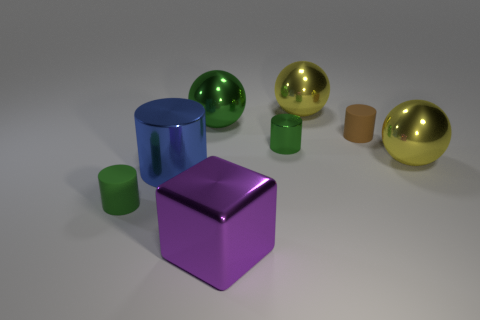Are there an equal number of brown rubber objects that are behind the large block and large green spheres?
Provide a short and direct response. Yes. Is the size of the brown cylinder the same as the yellow object that is right of the tiny brown rubber object?
Keep it short and to the point. No. What shape is the big yellow metal thing that is behind the tiny brown object?
Offer a terse response. Sphere. Is there anything else that has the same shape as the green matte thing?
Ensure brevity in your answer.  Yes. Are any small brown rubber cylinders visible?
Provide a short and direct response. Yes. There is a matte cylinder to the left of the small brown matte cylinder; is its size the same as the yellow metallic object behind the green metallic cylinder?
Your response must be concise. No. The small thing that is both right of the large purple object and in front of the brown object is made of what material?
Your response must be concise. Metal. There is a brown matte thing; what number of big yellow metallic objects are to the left of it?
Ensure brevity in your answer.  1. Is there anything else that is the same size as the purple shiny object?
Your answer should be compact. Yes. There is a small cylinder that is made of the same material as the purple block; what color is it?
Ensure brevity in your answer.  Green. 